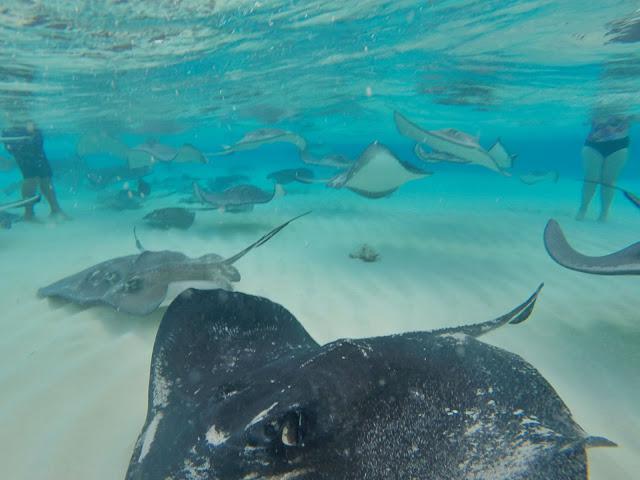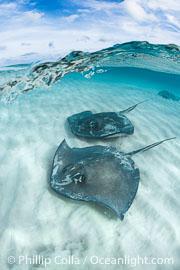The first image is the image on the left, the second image is the image on the right. Examine the images to the left and right. Is the description "The image on the left is taken from out of the water, and the image on the right is taken from in the water." accurate? Answer yes or no. No. The first image is the image on the left, the second image is the image on the right. Examine the images to the left and right. Is the description "The right image shows no human beings." accurate? Answer yes or no. Yes. 